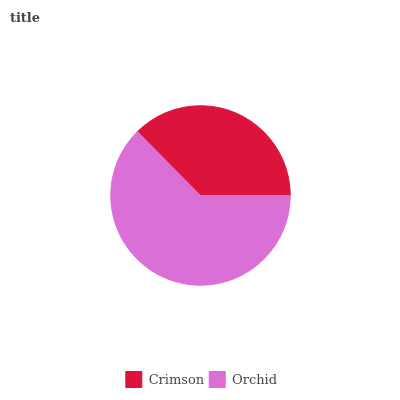Is Crimson the minimum?
Answer yes or no. Yes. Is Orchid the maximum?
Answer yes or no. Yes. Is Orchid the minimum?
Answer yes or no. No. Is Orchid greater than Crimson?
Answer yes or no. Yes. Is Crimson less than Orchid?
Answer yes or no. Yes. Is Crimson greater than Orchid?
Answer yes or no. No. Is Orchid less than Crimson?
Answer yes or no. No. Is Orchid the high median?
Answer yes or no. Yes. Is Crimson the low median?
Answer yes or no. Yes. Is Crimson the high median?
Answer yes or no. No. Is Orchid the low median?
Answer yes or no. No. 